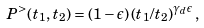Convert formula to latex. <formula><loc_0><loc_0><loc_500><loc_500>P ^ { > } ( t _ { 1 } , t _ { 2 } ) = ( 1 - \epsilon ) \left ( t _ { 1 } / t _ { 2 } \right ) ^ { \gamma _ { d } \epsilon } ,</formula> 